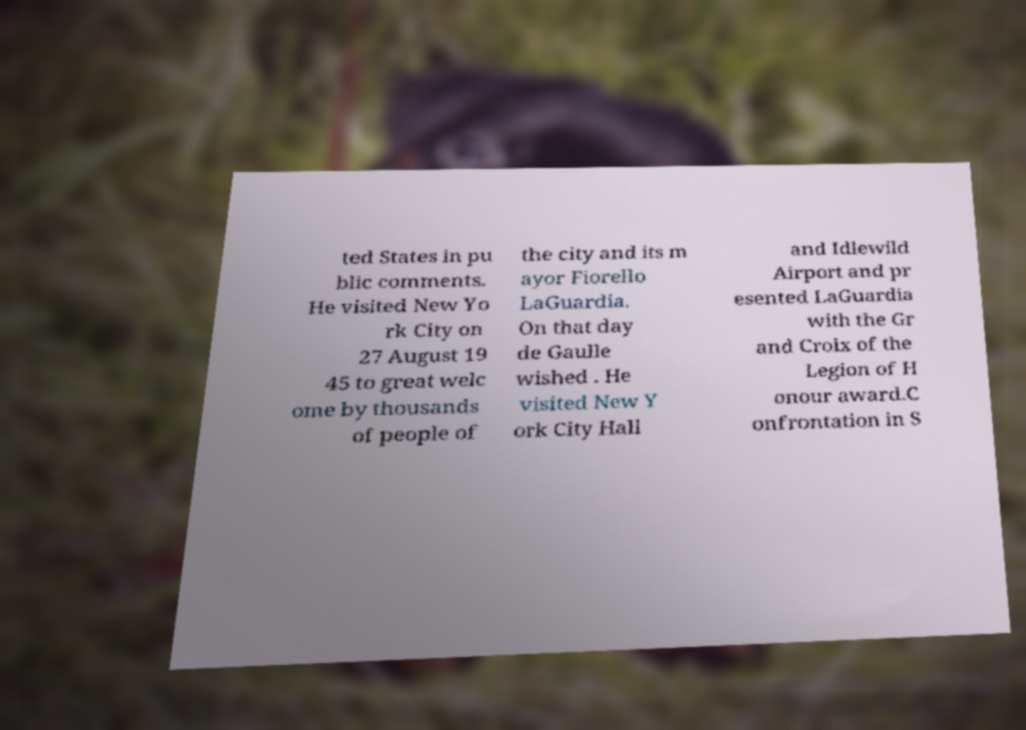Could you extract and type out the text from this image? ted States in pu blic comments. He visited New Yo rk City on 27 August 19 45 to great welc ome by thousands of people of the city and its m ayor Fiorello LaGuardia. On that day de Gaulle wished . He visited New Y ork City Hall and Idlewild Airport and pr esented LaGuardia with the Gr and Croix of the Legion of H onour award.C onfrontation in S 